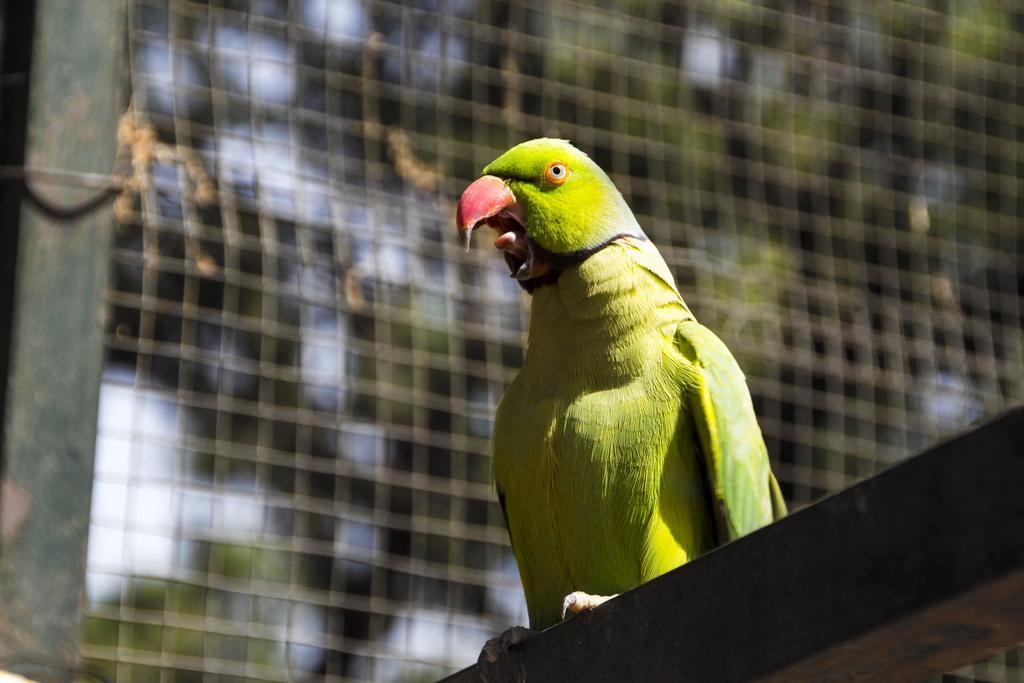Could you give a brief overview of what you see in this image? In this picture we can see a parrot in the middle of the image, in the background we can find fence and few trees. 